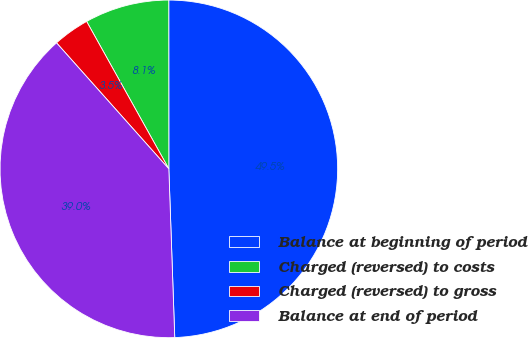Convert chart. <chart><loc_0><loc_0><loc_500><loc_500><pie_chart><fcel>Balance at beginning of period<fcel>Charged (reversed) to costs<fcel>Charged (reversed) to gross<fcel>Balance at end of period<nl><fcel>49.45%<fcel>8.09%<fcel>3.49%<fcel>38.97%<nl></chart> 